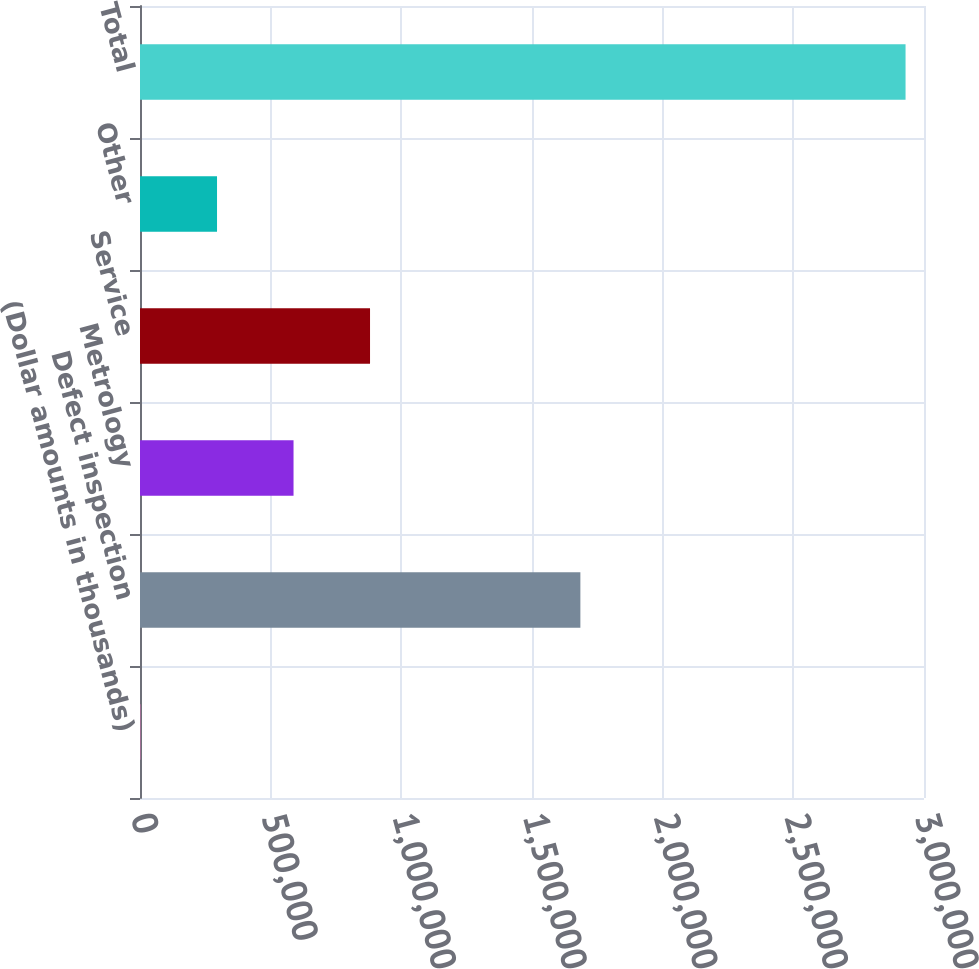Convert chart. <chart><loc_0><loc_0><loc_500><loc_500><bar_chart><fcel>(Dollar amounts in thousands)<fcel>Defect inspection<fcel>Metrology<fcel>Service<fcel>Other<fcel>Total<nl><fcel>2014<fcel>1.68511e+06<fcel>587493<fcel>880232<fcel>294753<fcel>2.92941e+06<nl></chart> 